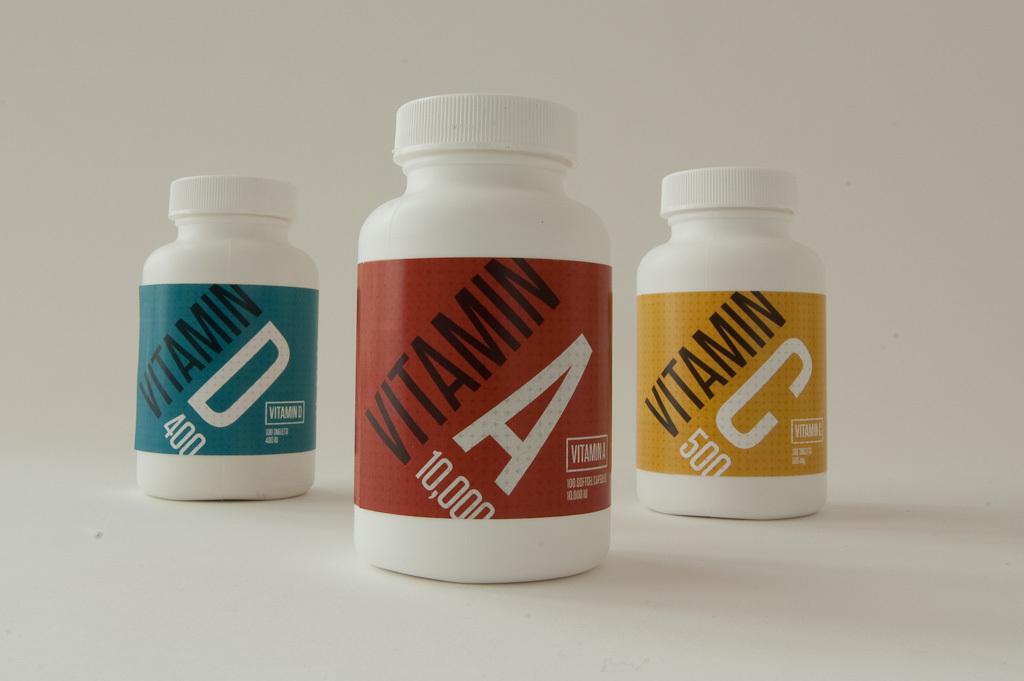What is the term in black text on the label?
Provide a short and direct response. Vitamin. What is the label of the front bottle?
Provide a short and direct response. Vitamin a. 